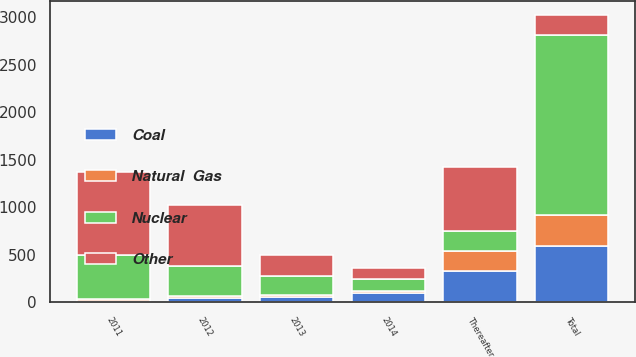Convert chart to OTSL. <chart><loc_0><loc_0><loc_500><loc_500><stacked_bar_chart><ecel><fcel>2011<fcel>2012<fcel>2013<fcel>2014<fcel>Thereafter<fcel>Total<nl><fcel>Other<fcel>874<fcel>639<fcel>218<fcel>120<fcel>675<fcel>207<nl><fcel>Nuclear<fcel>461<fcel>317<fcel>205<fcel>121<fcel>214<fcel>1898<nl><fcel>Coal<fcel>16<fcel>43<fcel>55<fcel>100<fcel>329<fcel>598<nl><fcel>Natural  Gas<fcel>22<fcel>22<fcel>22<fcel>22<fcel>207<fcel>317<nl></chart> 